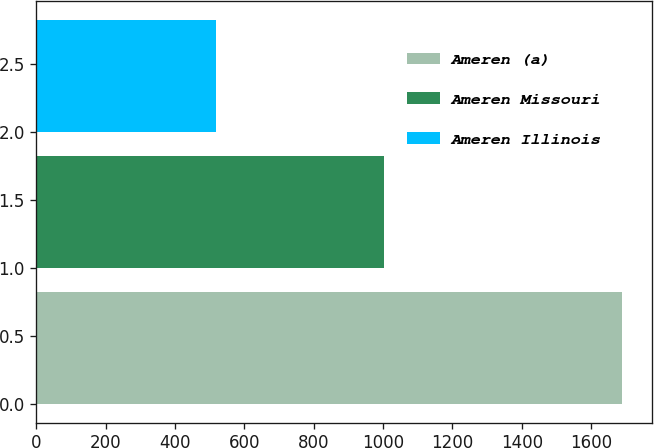<chart> <loc_0><loc_0><loc_500><loc_500><bar_chart><fcel>Ameren (a)<fcel>Ameren Missouri<fcel>Ameren Illinois<nl><fcel>1690<fcel>1004<fcel>519<nl></chart> 